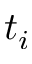Convert formula to latex. <formula><loc_0><loc_0><loc_500><loc_500>t _ { i }</formula> 